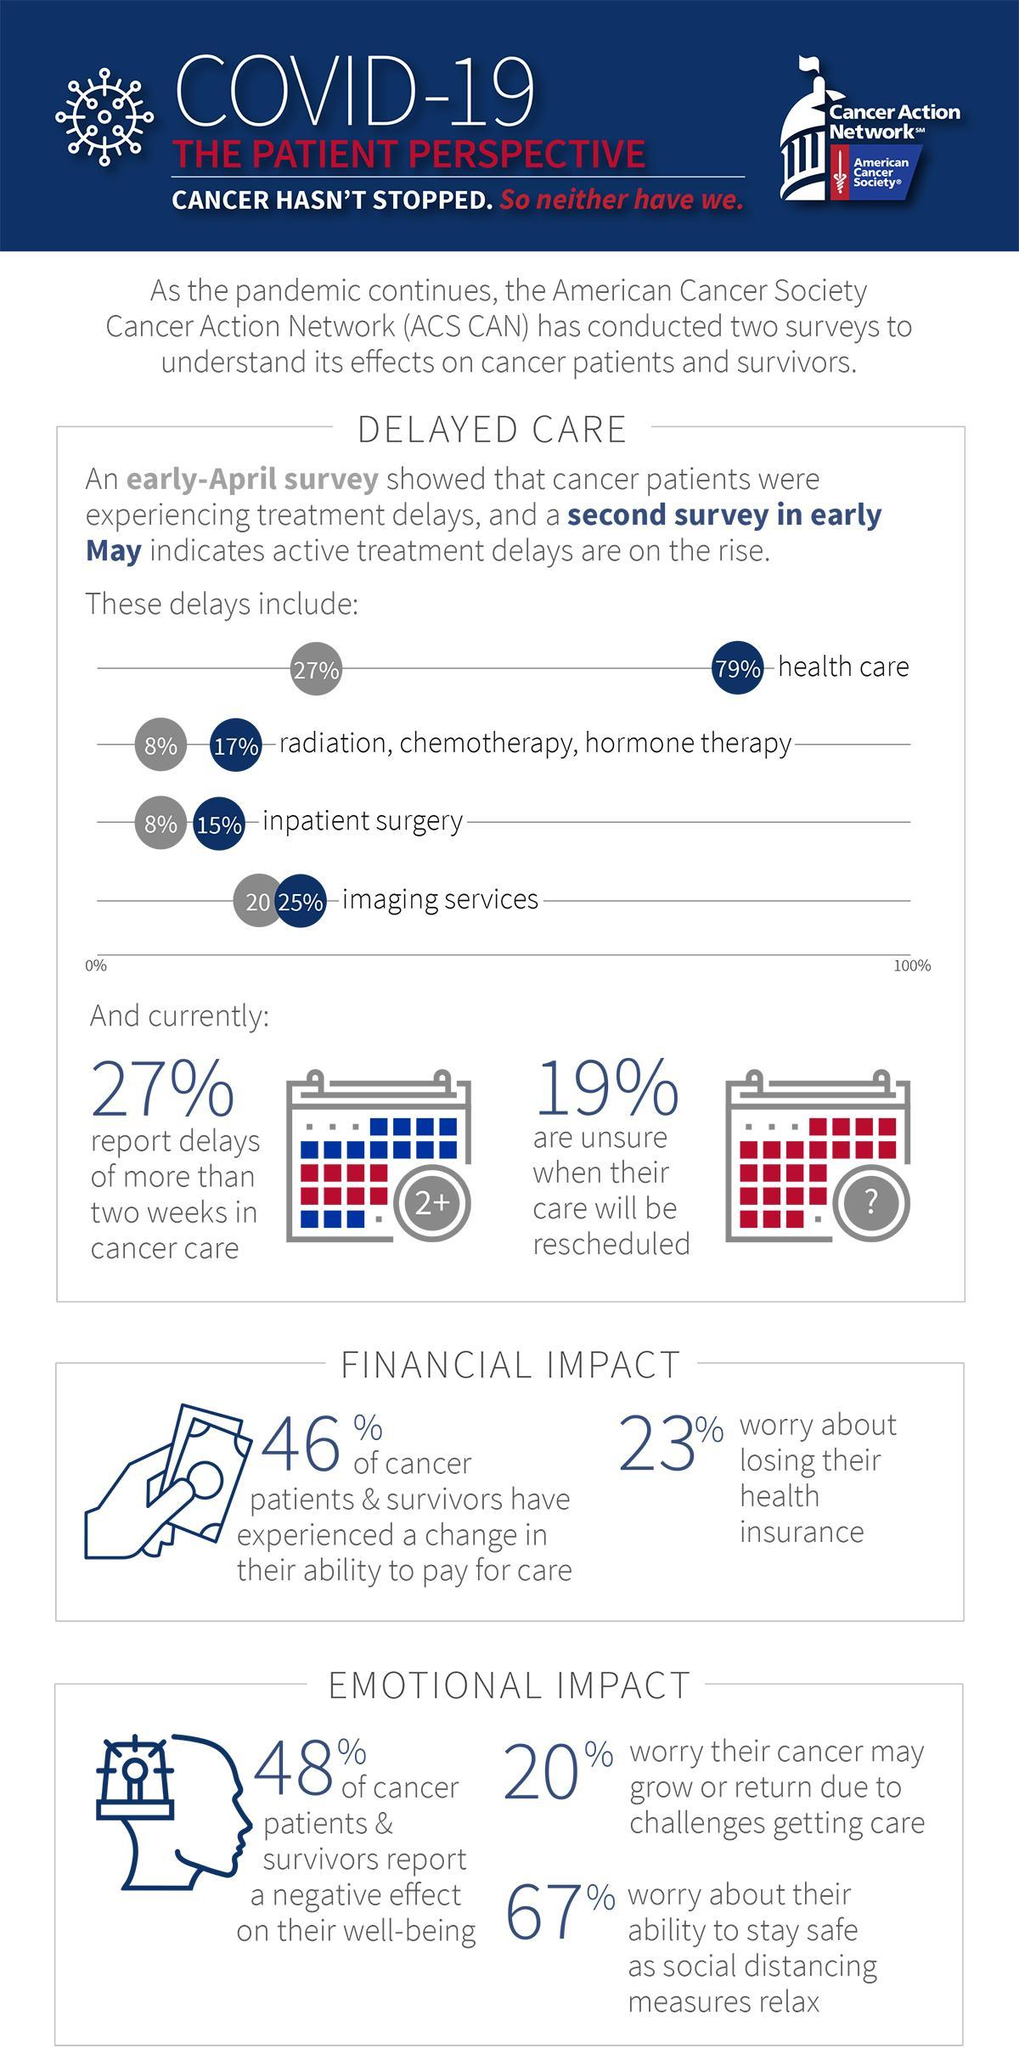What percent of cancer patients worry about losing their health insurance due to the impact of COVID-19?
Answer the question with a short phrase. 23% What percent of cancer patients experienced a delay in imaging services due to COVID-19 pandemic in an early-May survey conducted by ACS-CAN? 25% What percent of cancer patients experienced a delay in their inpatient surgery due to COVID-19 pandemic in an early-April survey conducted by ACS-CAN? 8% What percent of cancer patients reported delay of more than two weeks in cancer care due to the impact of COVID-19? 27% 